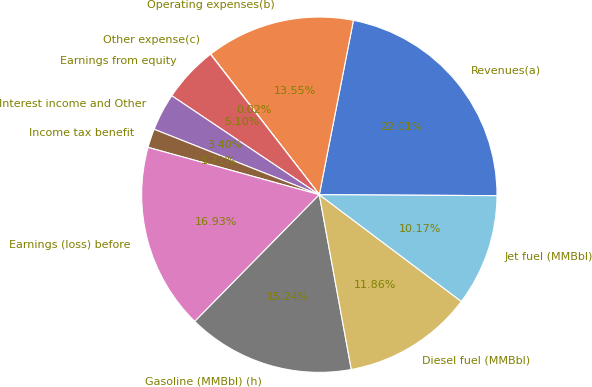Convert chart. <chart><loc_0><loc_0><loc_500><loc_500><pie_chart><fcel>Revenues(a)<fcel>Operating expenses(b)<fcel>Other expense(c)<fcel>Earnings from equity<fcel>Interest income and Other<fcel>Income tax benefit<fcel>Earnings (loss) before<fcel>Gasoline (MMBbl) (h)<fcel>Diesel fuel (MMBbl)<fcel>Jet fuel (MMBbl)<nl><fcel>22.01%<fcel>13.55%<fcel>0.02%<fcel>5.1%<fcel>3.4%<fcel>1.71%<fcel>16.93%<fcel>15.24%<fcel>11.86%<fcel>10.17%<nl></chart> 